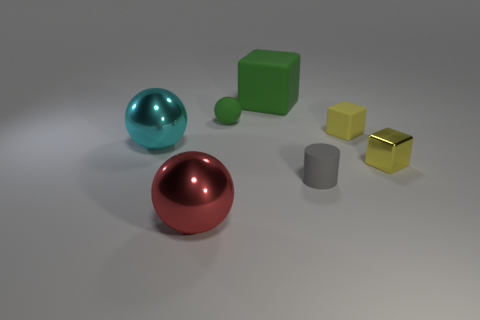There is a thing behind the green rubber ball; what is its size? The object behind the green rubber ball appears to be a red sphere, and judging by the relative scale of objects in the image, its size could be described as medium to large compared to the ball. 